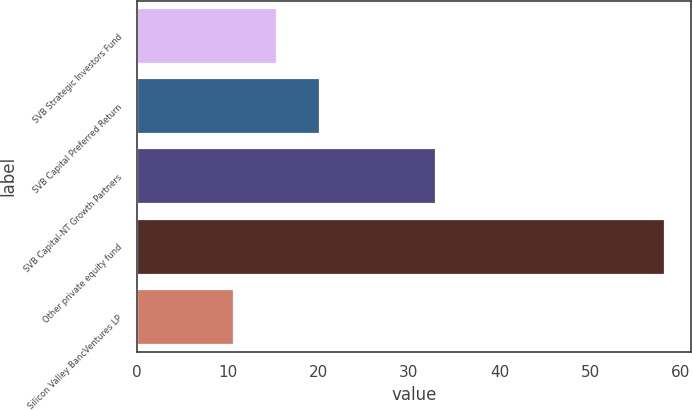Convert chart to OTSL. <chart><loc_0><loc_0><loc_500><loc_500><bar_chart><fcel>SVB Strategic Investors Fund<fcel>SVB Capital Preferred Return<fcel>SVB Capital-NT Growth Partners<fcel>Other private equity fund<fcel>Silicon Valley BancVentures LP<nl><fcel>15.45<fcel>20.2<fcel>33<fcel>58.2<fcel>10.7<nl></chart> 